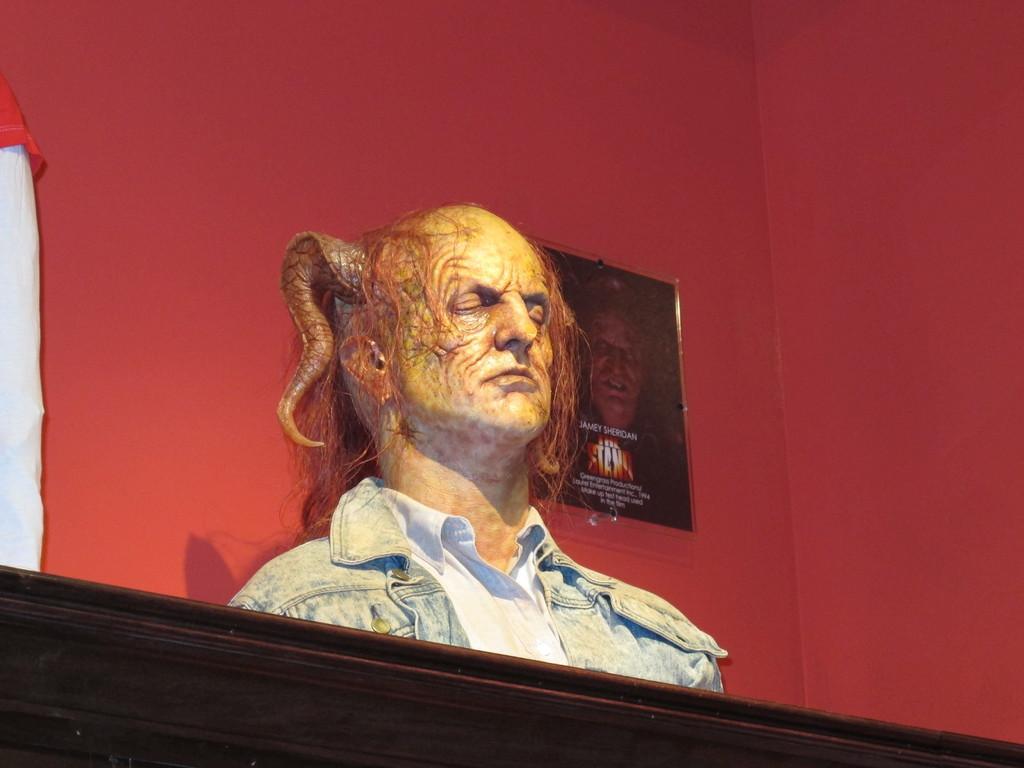Please provide a concise description of this image. In this picture there is a statue of the man face with horn on the head is placed on the wooden rafter. Behind there is a red color wall with hanging photo frame. 